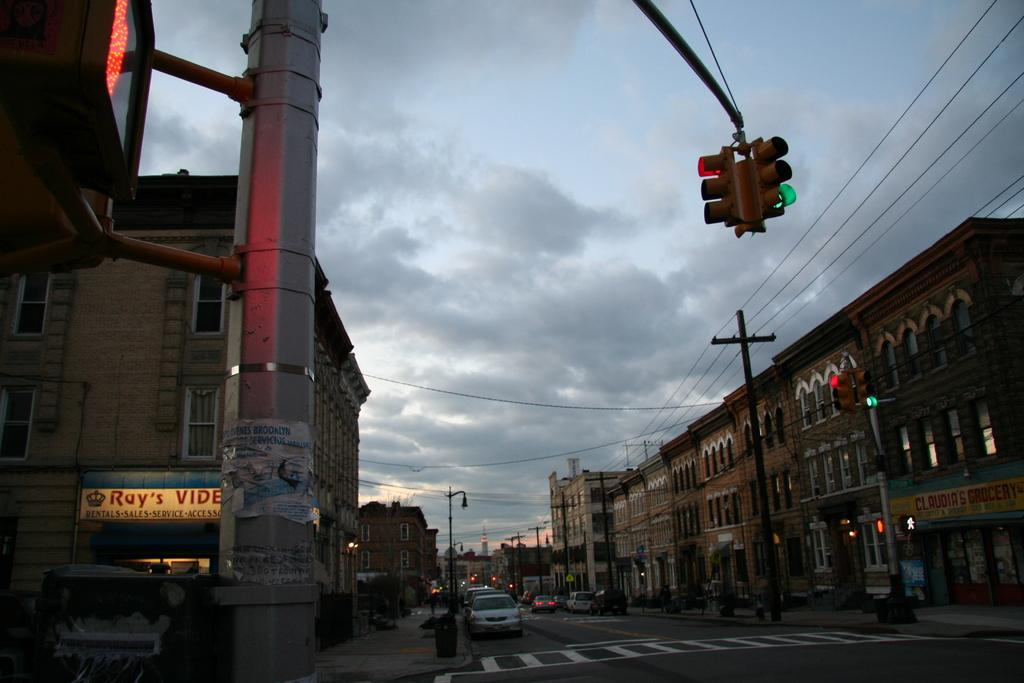<image>
Render a clear and concise summary of the photo. Ray's video store has an illuminated sign as the sun sets on the city street. 